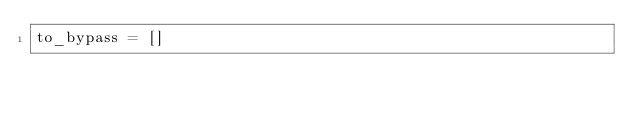<code> <loc_0><loc_0><loc_500><loc_500><_Python_>to_bypass = []
</code> 